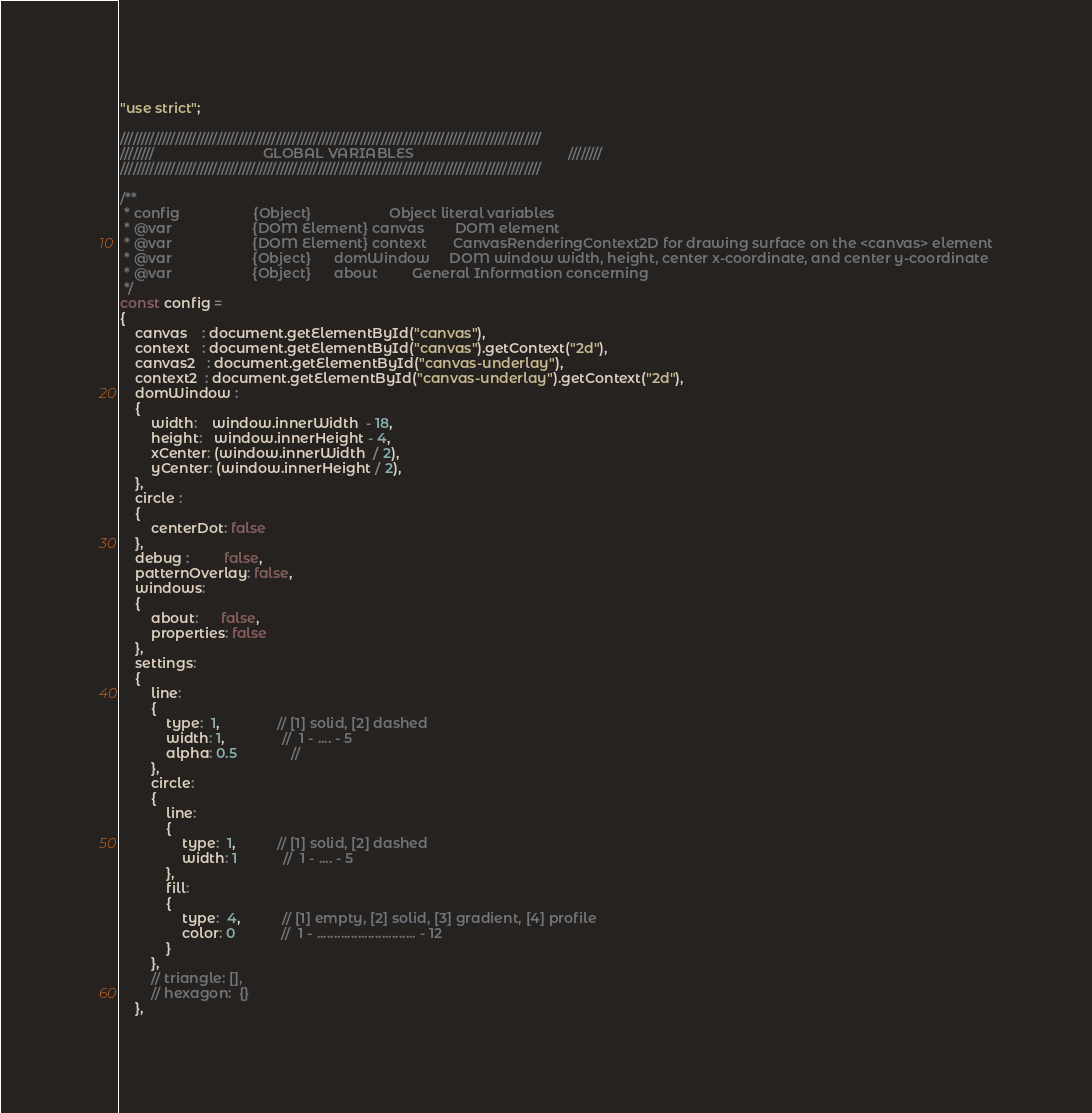<code> <loc_0><loc_0><loc_500><loc_500><_JavaScript_>"use strict";

////////////////////////////////////////////////////////////////////////////////////////////////////
////////                            GLOBAL VARIABLES                                        ////////
////////////////////////////////////////////////////////////////////////////////////////////////////

/**
 * config                   {Object}                    Object literal variables
 * @var                     {DOM Element} canvas        DOM element
 * @var                     {DOM Element} context       CanvasRenderingContext2D for drawing surface on the <canvas> element
 * @var                     {Object}      domWindow     DOM window width, height, center x-coordinate, and center y-coordinate
 * @var                     {Object}      about         General Information concerning  
 */
const config = 
{
    canvas    : document.getElementById("canvas"),
    context   : document.getElementById("canvas").getContext("2d"),
    canvas2   : document.getElementById("canvas-underlay"),
    context2  : document.getElementById("canvas-underlay").getContext("2d"),
    domWindow : 
    {
        width:    window.innerWidth  - 18,
        height:   window.innerHeight - 4,
        xCenter: (window.innerWidth  / 2),
        yCenter: (window.innerHeight / 2),
    },
    circle : 
    {
        centerDot: false
    },
    debug :         false,
    patternOverlay: false,
    windows:
    {
        about:      false,
        properties: false
    },
    settings:
    {
        line:
        {
            type:  1,               // [1] solid, [2] dashed
            width: 1,               //  1 - .... - 5
            alpha: 0.5              //  
        },
        circle:   
        {
            line: 
            {
                type:  1,           // [1] solid, [2] dashed
                width: 1            //  1 - .... - 5
            },
            fill:
            {
                type:  4,           // [1] empty, [2] solid, [3] gradient, [4] profile
                color: 0            //  1 - ............................. - 12
            }
        },
        // triangle: [],
        // hexagon:  {}
    },</code> 